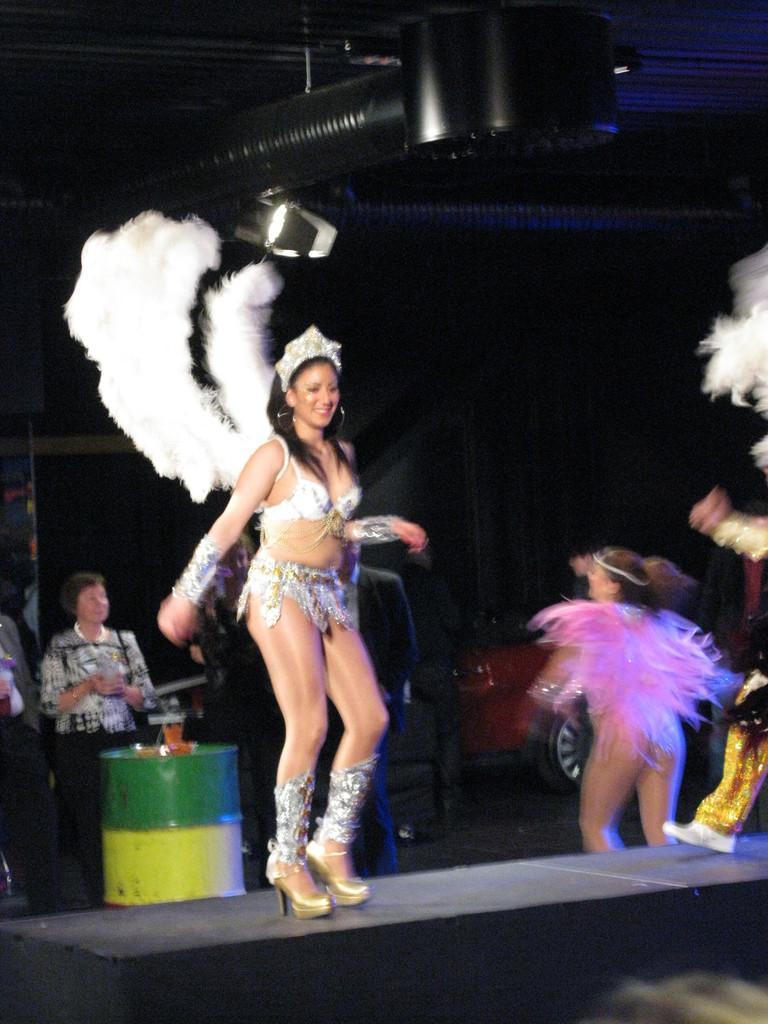Please provide a concise description of this image. In the center of the image there are two ladies wearing costumes and dancing. On the left there are people standing. In the background there is a car, drum and a stage. 